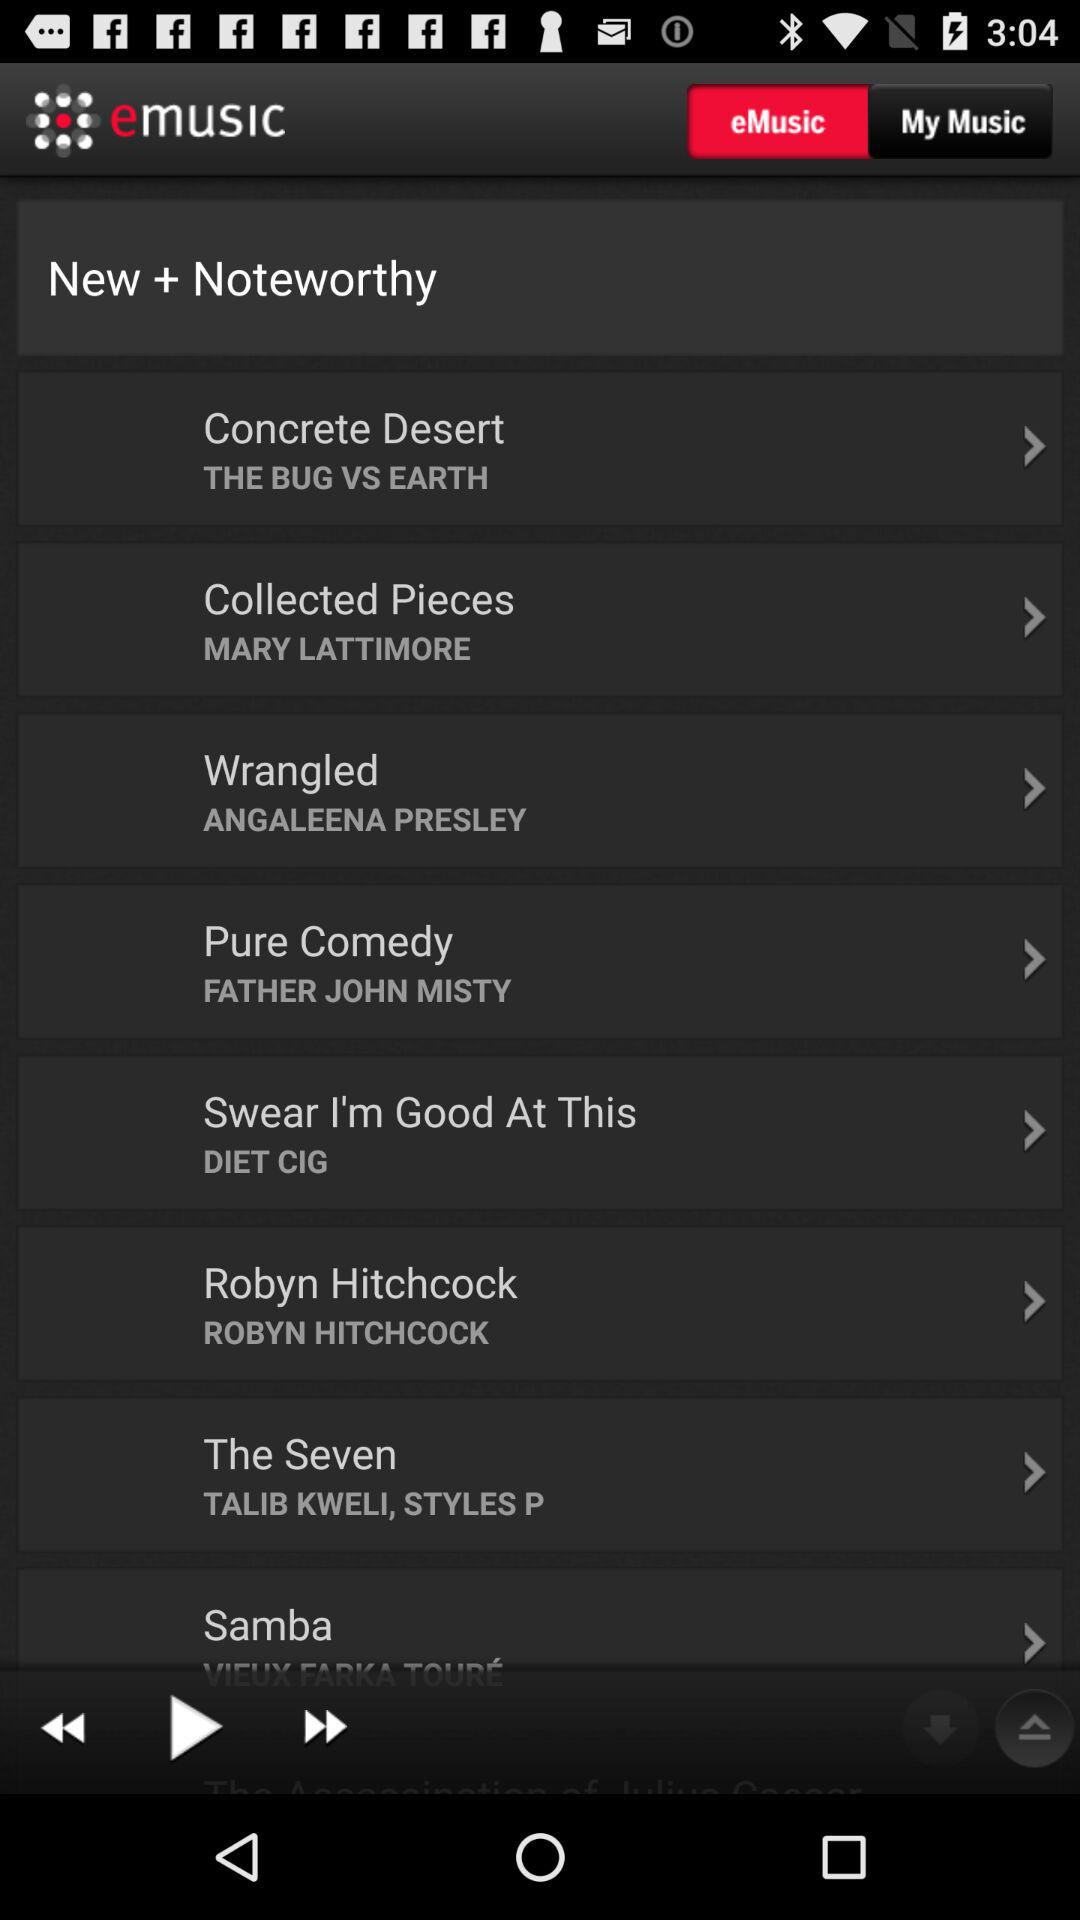What is the name of the "Wrangled" artist? The name of the "Wrangled" artist is Angaleena Presley. 